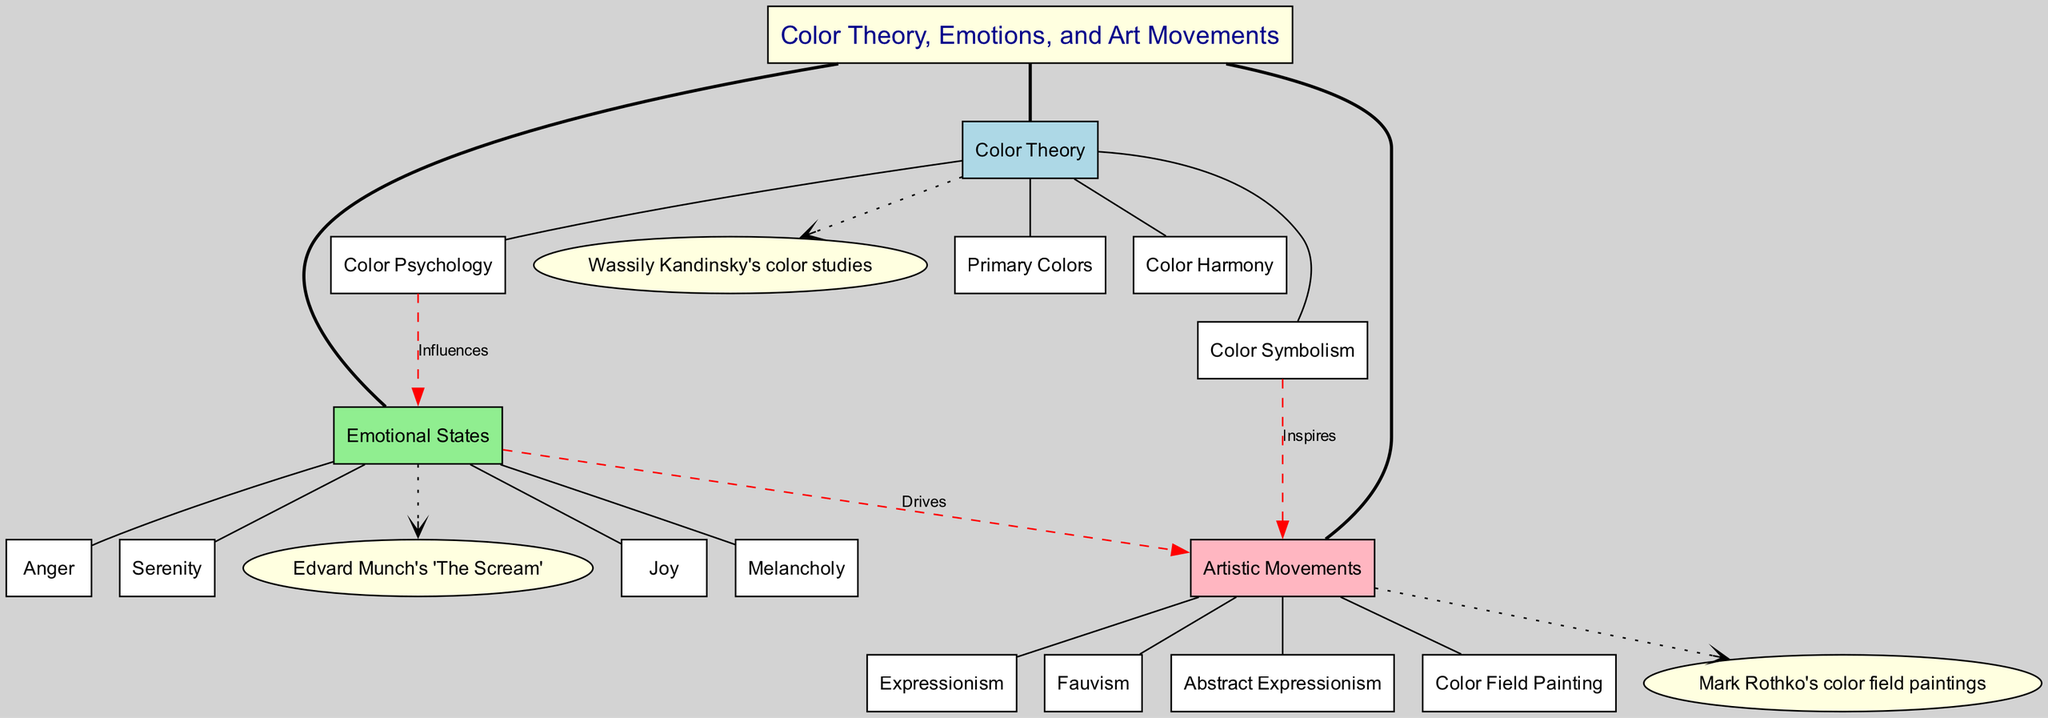What is the central topic of the diagram? The central topic is indicated at the center of the diagram and should provide a clear summary of the main themes being explored. In this case, it is "Color Theory, Emotions, and Art Movements."
Answer: Color Theory, Emotions, and Art Movements How many main branches are in the diagram? The diagram includes three main branches connected to the central topic. Each of these branches represents different aspects of the central theme: Color Theory, Emotional States, and Artistic Movements.
Answer: 3 Which emotional state is directly connected to the artistic movement of Expressionism? The connections from the Emotional States branch indicate that the emotional states influence the artistic movements. By checking the connections, we see that multiple emotional states drive the artistic movements, including Expressionism related to Joy and Melancholy.
Answer: Joy and Melancholy What type of artistic movement is associated with color symbolism? A dashed line labeled "Inspires" connects Color Symbolism to Artistic Movements in the diagram. By identifying the sub-branches, we see that Color Symbolism influences movements like Fauvism and Expressionism.
Answer: Fauvism and Expressionism Name an example of Color Theory from the diagram. The diagram provides examples for each branch. By looking at the examples listed under Color Theory, we find that Wassily Kandinsky's color studies are provided as a specific example.
Answer: Wassily Kandinsky's color studies How do emotional states drive artistic movements? The diagram shows a connection labeled "Drives" from Emotional States to Artistic Movements, indicating that various emotions such as Joy, Melancholy, and Anger directly influence the development and style of artistic movements like Expressionism and Abstract Expressionism.
Answer: By influencing the artistic expressions and themes depicted Which color theory concept influences emotional states? The "Color Psychology" sub-branch directly connects to Emotional States in the diagram with a labeled influence. This indicates that different colors can evoke specific emotions, leading to a relationship where color choices impact viewers' emotional responses.
Answer: Color Psychology What color does the primary branch of Color Theory focus on? The diagram's main branch labeled "Color Theory" contains relevant sub-branches. Although color theory encompasses a broad scope, the sub-branch "Primary Colors" explicitly refers to the foundational elements of color.
Answer: Primary Colors How are emotional states related to artistic movements in the diagram? The multiple connections from the Emotional States to the Artistic Movements with the label "Drives" suggest a direct relationship. Emotional states such as Joy and Melancholy can inspire specific art styles, including Expressionism, impacting how emotions are represented artistically.
Answer: By inspiring various styles in art 